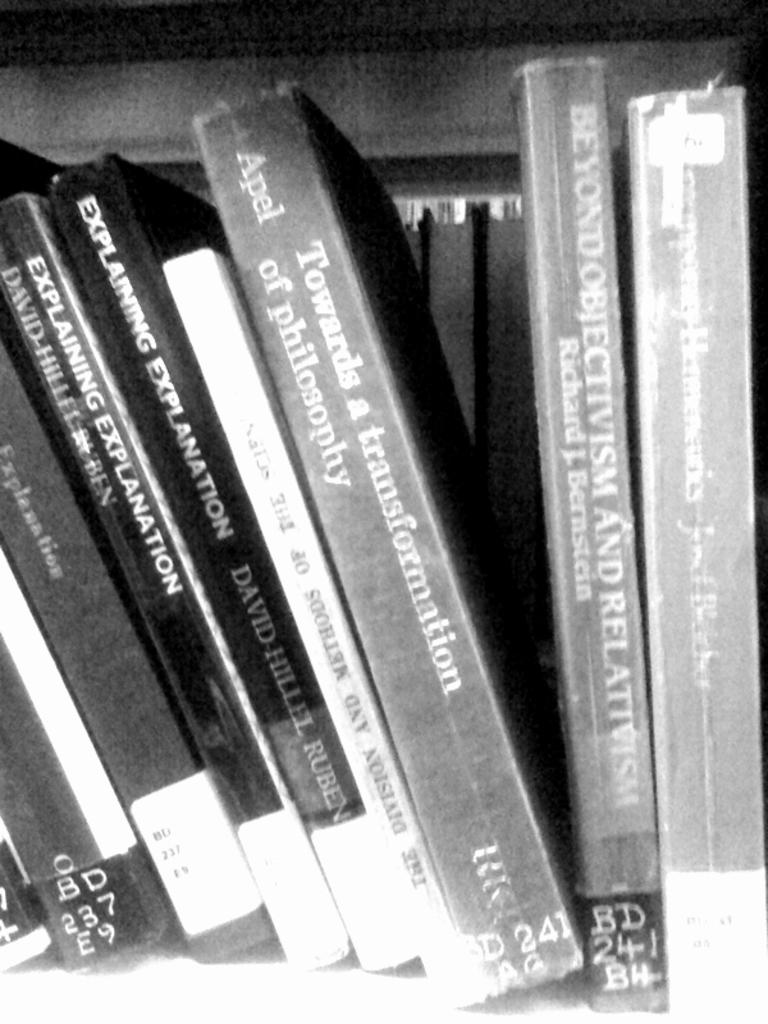Who wrote explaining explanation?
Your answer should be very brief. David hillel ruben. What is the title of the first book?
Offer a terse response. Explaining explanation. 